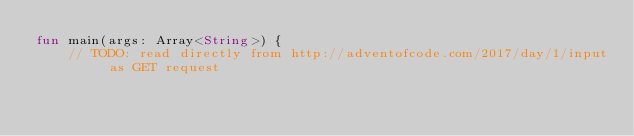Convert code to text. <code><loc_0><loc_0><loc_500><loc_500><_Kotlin_>fun main(args: Array<String>) {
    // TODO: read directly from http://adventofcode.com/2017/day/1/input as GET request</code> 